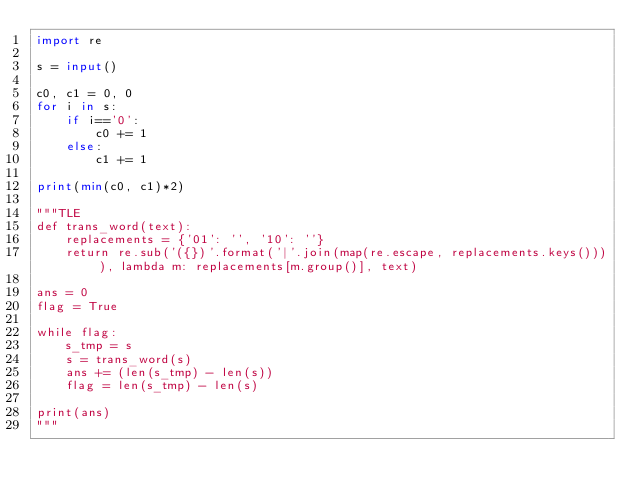Convert code to text. <code><loc_0><loc_0><loc_500><loc_500><_Python_>import re

s = input()

c0, c1 = 0, 0
for i in s:
    if i=='0':
        c0 += 1
    else:
        c1 += 1

print(min(c0, c1)*2)

"""TLE
def trans_word(text):
    replacements = {'01': '', '10': ''}
    return re.sub('({})'.format('|'.join(map(re.escape, replacements.keys()))), lambda m: replacements[m.group()], text)

ans = 0
flag = True

while flag:
    s_tmp = s
    s = trans_word(s)
    ans += (len(s_tmp) - len(s))
    flag = len(s_tmp) - len(s)

print(ans)
"""</code> 